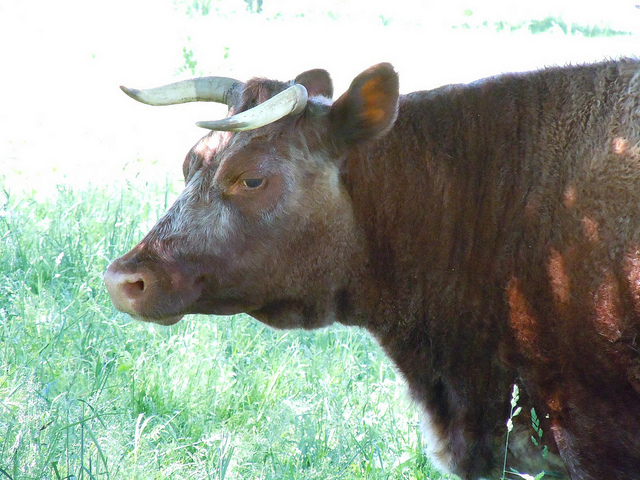Can you tell me about this animal's habitat and where it is typically found? The Longhorn breed of cattle originates from the Iberian Peninsula and was brought over to North America. These animals are highly adaptable and are commonly found in the southwestern United States. They thrive in various environments, often in open ranges where they graze on grasses and shrubs. 